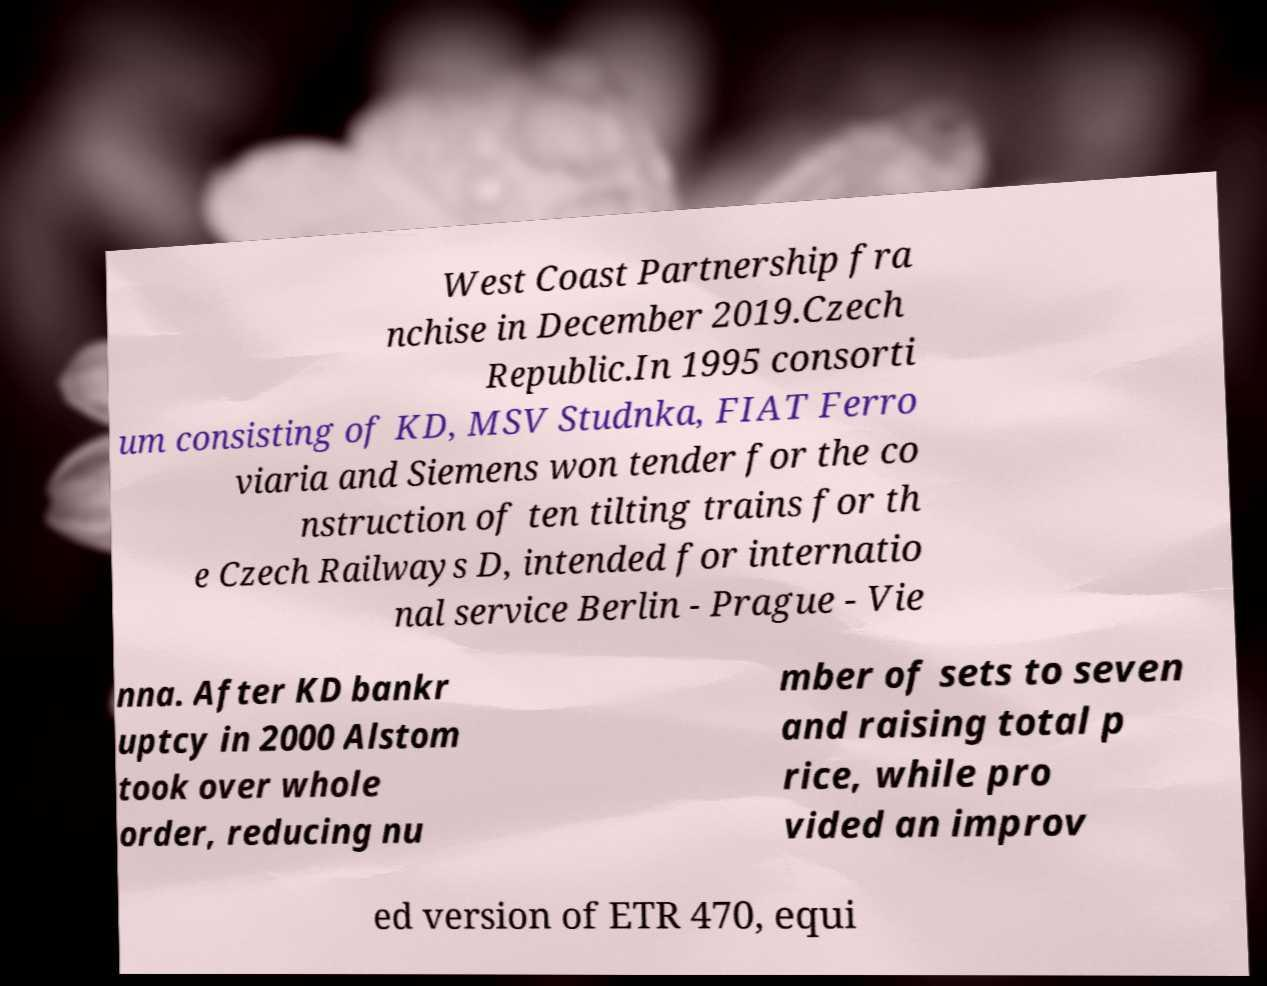For documentation purposes, I need the text within this image transcribed. Could you provide that? West Coast Partnership fra nchise in December 2019.Czech Republic.In 1995 consorti um consisting of KD, MSV Studnka, FIAT Ferro viaria and Siemens won tender for the co nstruction of ten tilting trains for th e Czech Railways D, intended for internatio nal service Berlin - Prague - Vie nna. After KD bankr uptcy in 2000 Alstom took over whole order, reducing nu mber of sets to seven and raising total p rice, while pro vided an improv ed version of ETR 470, equi 